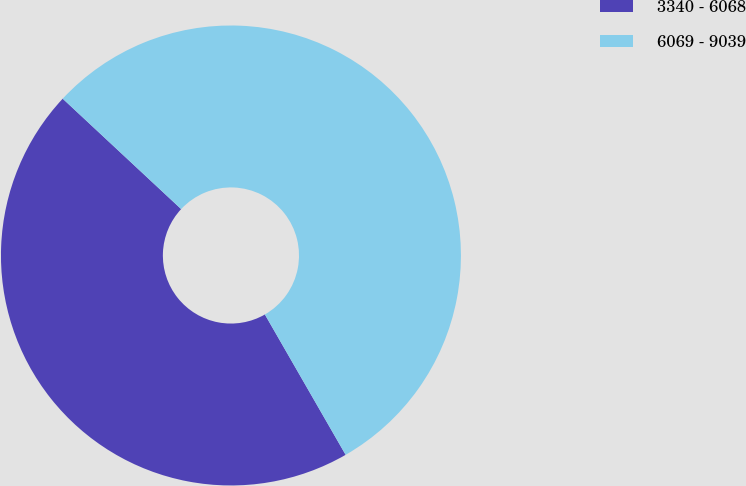Convert chart. <chart><loc_0><loc_0><loc_500><loc_500><pie_chart><fcel>3340 - 6068<fcel>6069 - 9039<nl><fcel>45.25%<fcel>54.75%<nl></chart> 